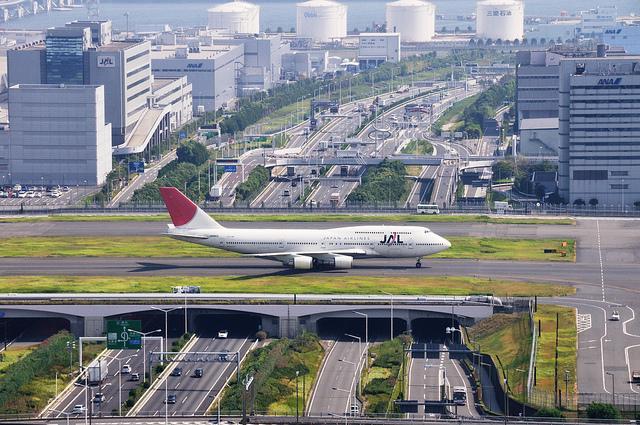What color is the tail of the plane?
Short answer required. Red. Is the plane made by Eurojet?
Be succinct. No. What airport is this plane at?
Concise answer only. Major airport. 